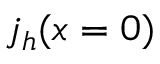Convert formula to latex. <formula><loc_0><loc_0><loc_500><loc_500>j _ { h } ( x = 0 )</formula> 